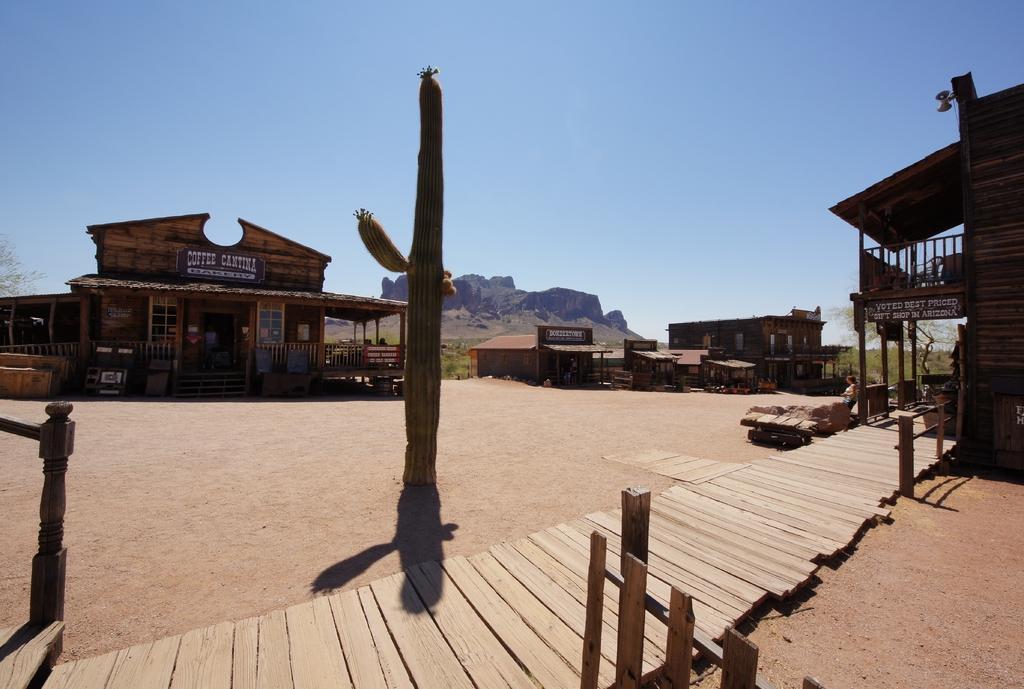Please provide a concise description of this image. In this image I can see the wooden path and the plant. In the background I can see many houses with windows. There are boards to the houses. I can also see the mountain, trees and the sky. 